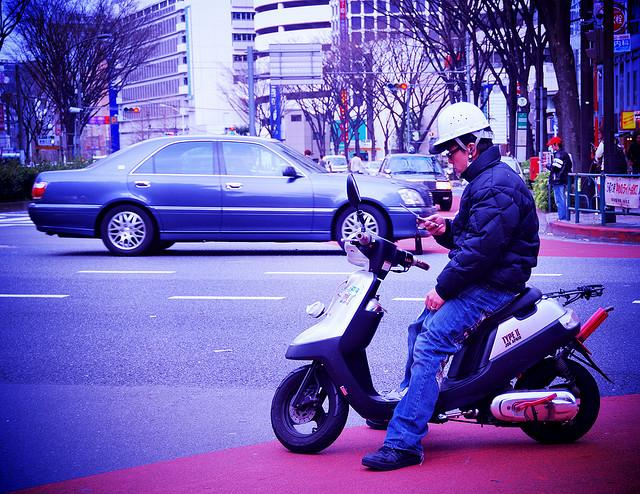In what country is this street found? japan 